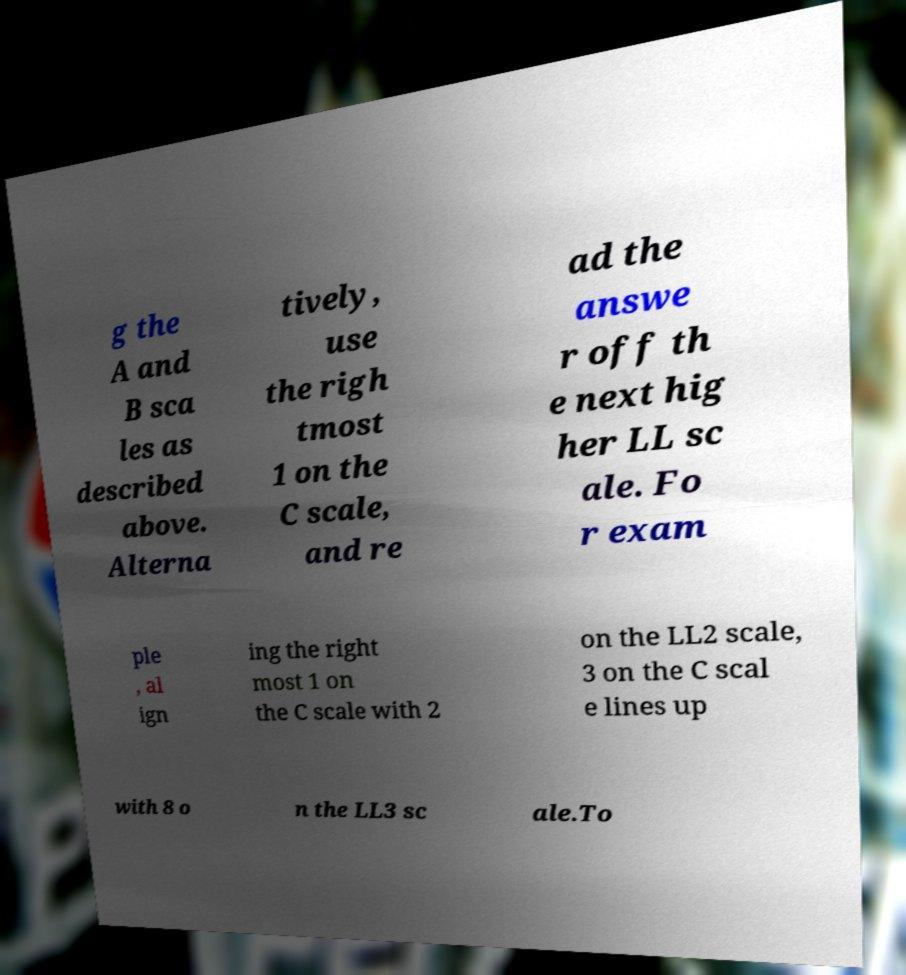There's text embedded in this image that I need extracted. Can you transcribe it verbatim? g the A and B sca les as described above. Alterna tively, use the righ tmost 1 on the C scale, and re ad the answe r off th e next hig her LL sc ale. Fo r exam ple , al ign ing the right most 1 on the C scale with 2 on the LL2 scale, 3 on the C scal e lines up with 8 o n the LL3 sc ale.To 